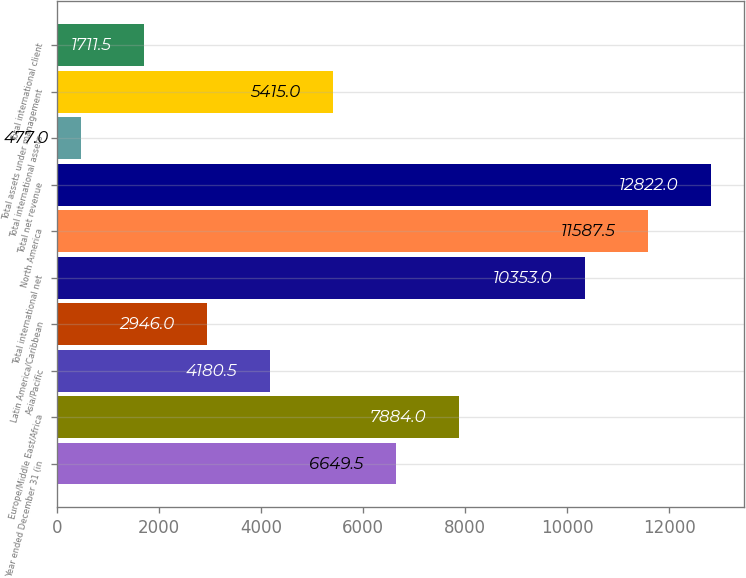Convert chart to OTSL. <chart><loc_0><loc_0><loc_500><loc_500><bar_chart><fcel>Year ended December 31 (in<fcel>Europe/Middle East/Africa<fcel>Asia/Pacific<fcel>Latin America/Caribbean<fcel>Total international net<fcel>North America<fcel>Total net revenue<fcel>Total international assets<fcel>Total assets under management<fcel>Total international client<nl><fcel>6649.5<fcel>7884<fcel>4180.5<fcel>2946<fcel>10353<fcel>11587.5<fcel>12822<fcel>477<fcel>5415<fcel>1711.5<nl></chart> 